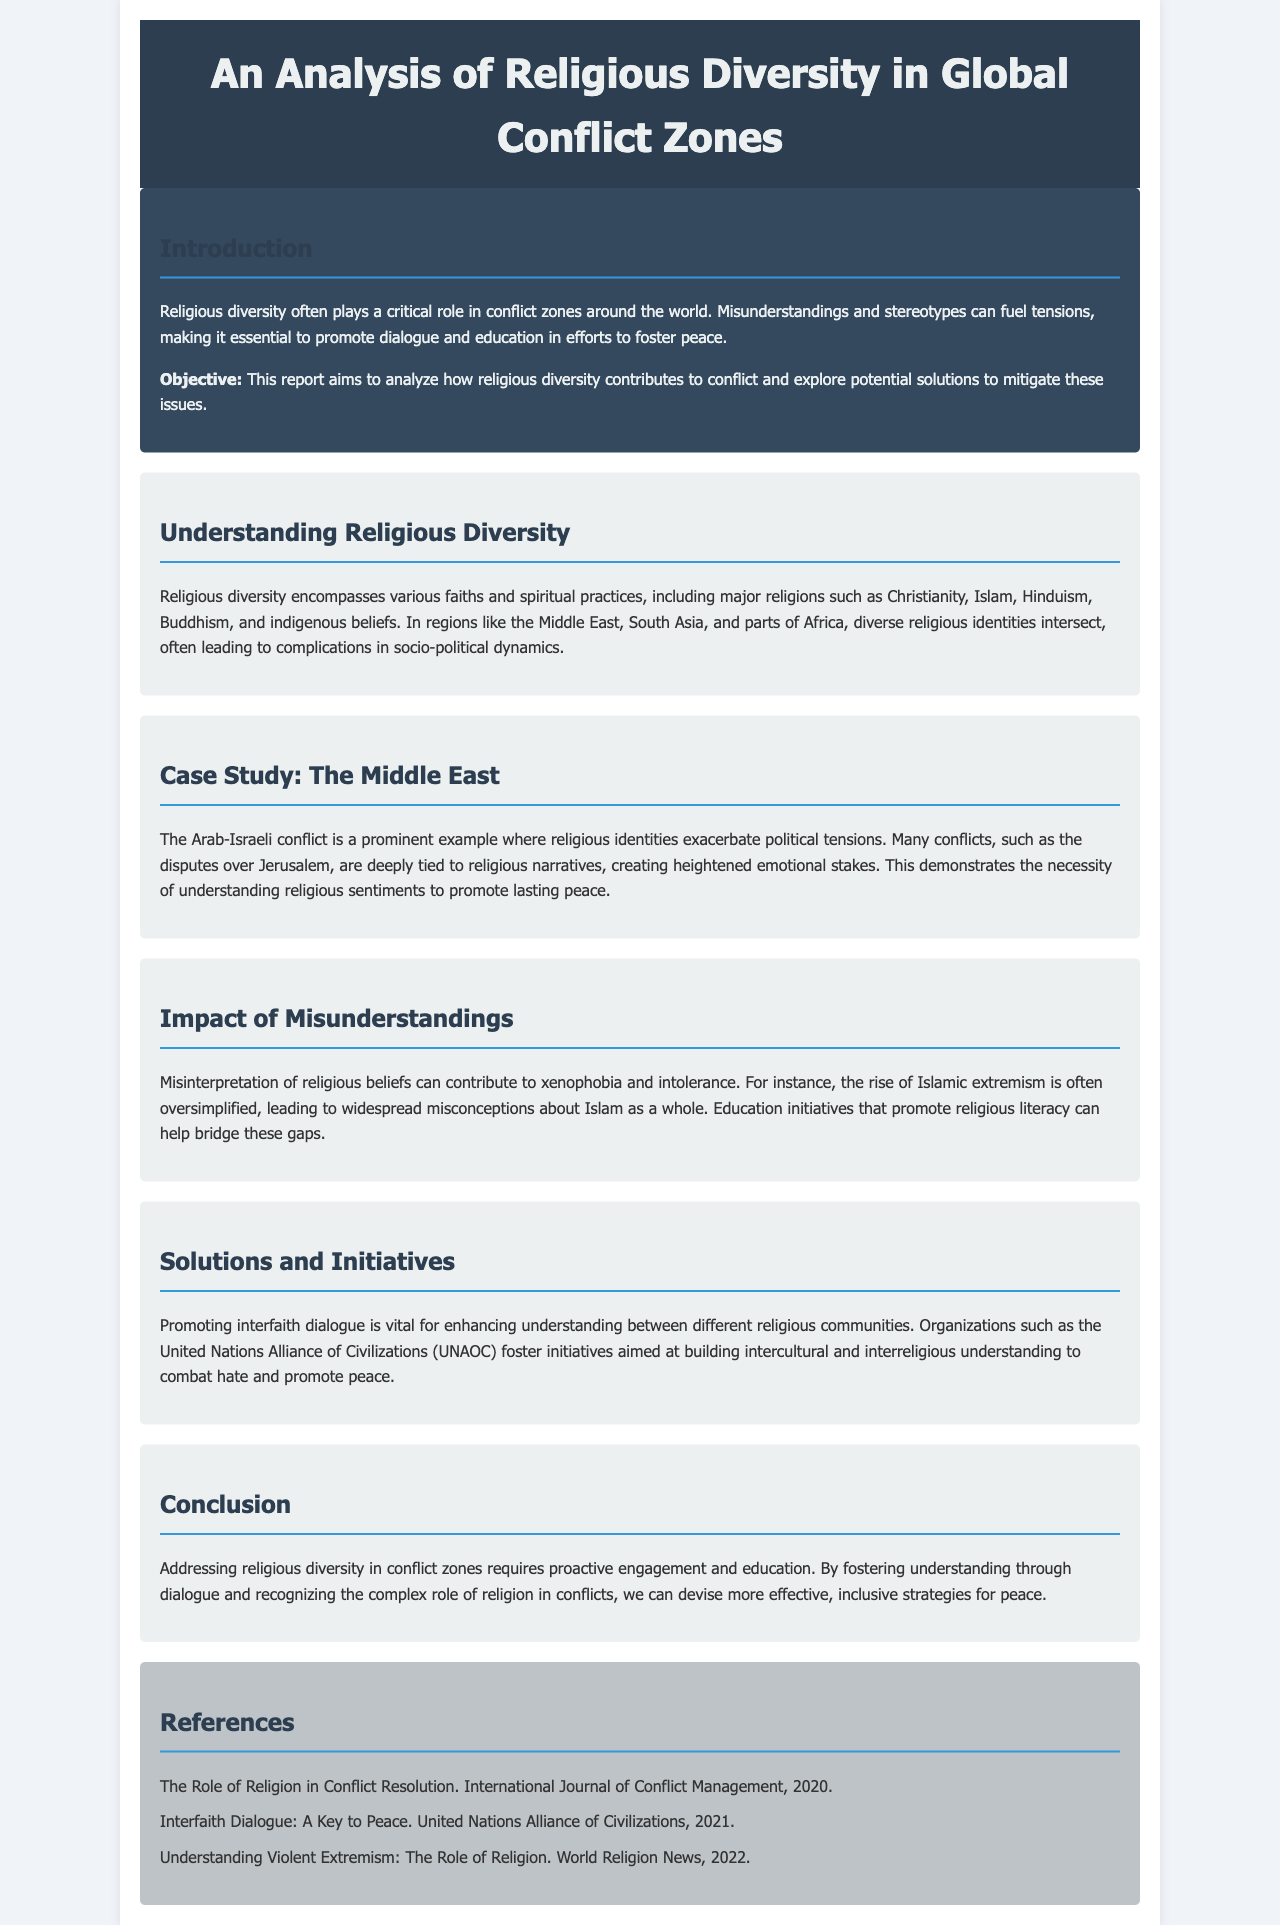what is the title of the report? The title of the report is stated at the top of the document.
Answer: An Analysis of Religious Diversity in Global Conflict Zones what is the objective of the report? The objective of the report is mentioned in the introduction section.
Answer: To analyze how religious diversity contributes to conflict and explore potential solutions to mitigate these issues which region is highlighted in the case study? The region emphasized in the case study section of the document is specified.
Answer: The Middle East what major theme is explored in the "Impact of Misunderstandings" section? This section discusses how misinterpretation can lead to negative societal outcomes.
Answer: Xenophobia and intolerance which organization is mentioned as fostering interfaith dialogue? The specific organization that features in the solutions section is indicated in the text.
Answer: United Nations Alliance of Civilizations (UNAOC) what is one proposed solution to address religious diversity in conflict zones? A suggested course of action is discussed within the Solutions and Initiatives section of the document.
Answer: Promoting interfaith dialogue what is the primary focus of the introduction? The primary focus is to establish the context and importance of the study presented in the report.
Answer: Religious diversity's role in conflict zones how many references are listed in the document? The number of references can be found in the references section at the end of the document.
Answer: Three 